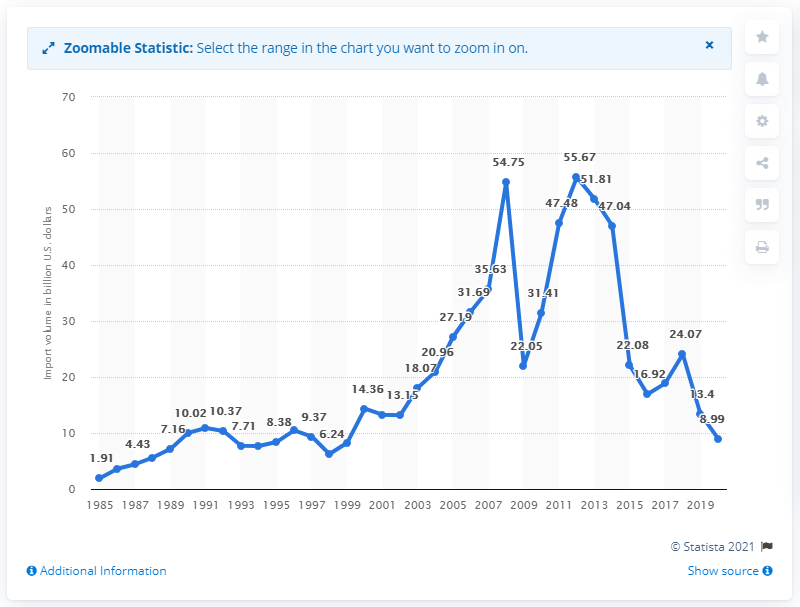Draw attention to some important aspects in this diagram. The value of imports from Saudi Arabia in dollars in 2020 was 8.99. 